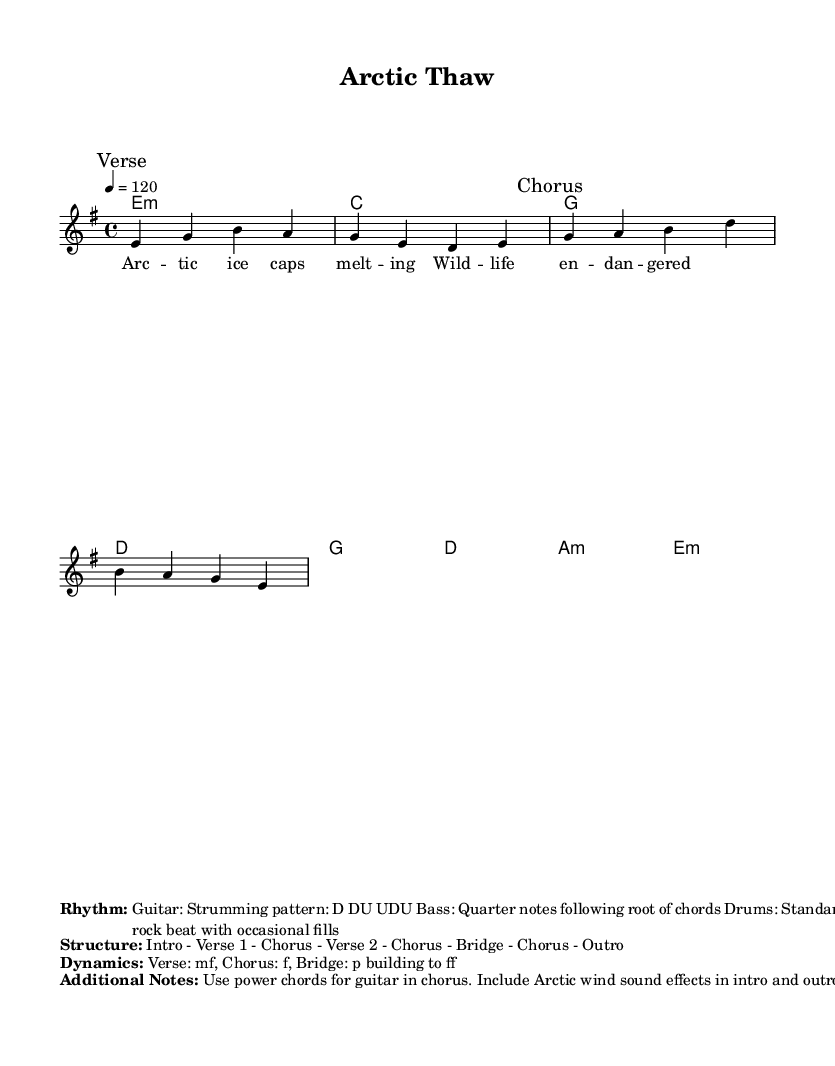What is the key signature of this music? The key signature shown is E minor, which typically includes one sharp (F#) and is indicated at the beginning of the staff.
Answer: E minor What is the time signature of this music? The time signature presented is 4/4, indicating that there are four beats in each measure and the quarter note receives one beat.
Answer: 4/4 What is the tempo marking for this piece? The tempo marking is given as 120, indicating that there should be 120 beats per minute. This is found above the staff notation.
Answer: 120 How many verses are in the song structure? The provided structure includes two verses, as indicated by "Verse 1" and "Verse 2" in the song's outline.
Answer: 2 What is the dynamic marking for the chorus? The dynamic marking for the chorus indicates "f," which stands for forte, meaning it should be played loudly. This is stated in the dynamics section.
Answer: f What is the strumming pattern for the guitar? The strumming pattern for the guitar is depicted as D DU UDU, which indicates a specific sequence of down and up strokes for rhythm.
Answer: D DU UDU What additional element is suggested for the introduction and outro? The additional element suggested for both the introduction and outro is "Arctic wind sound effects," which adds an atmospheric touch to the piece.
Answer: Arctic wind sound effects 